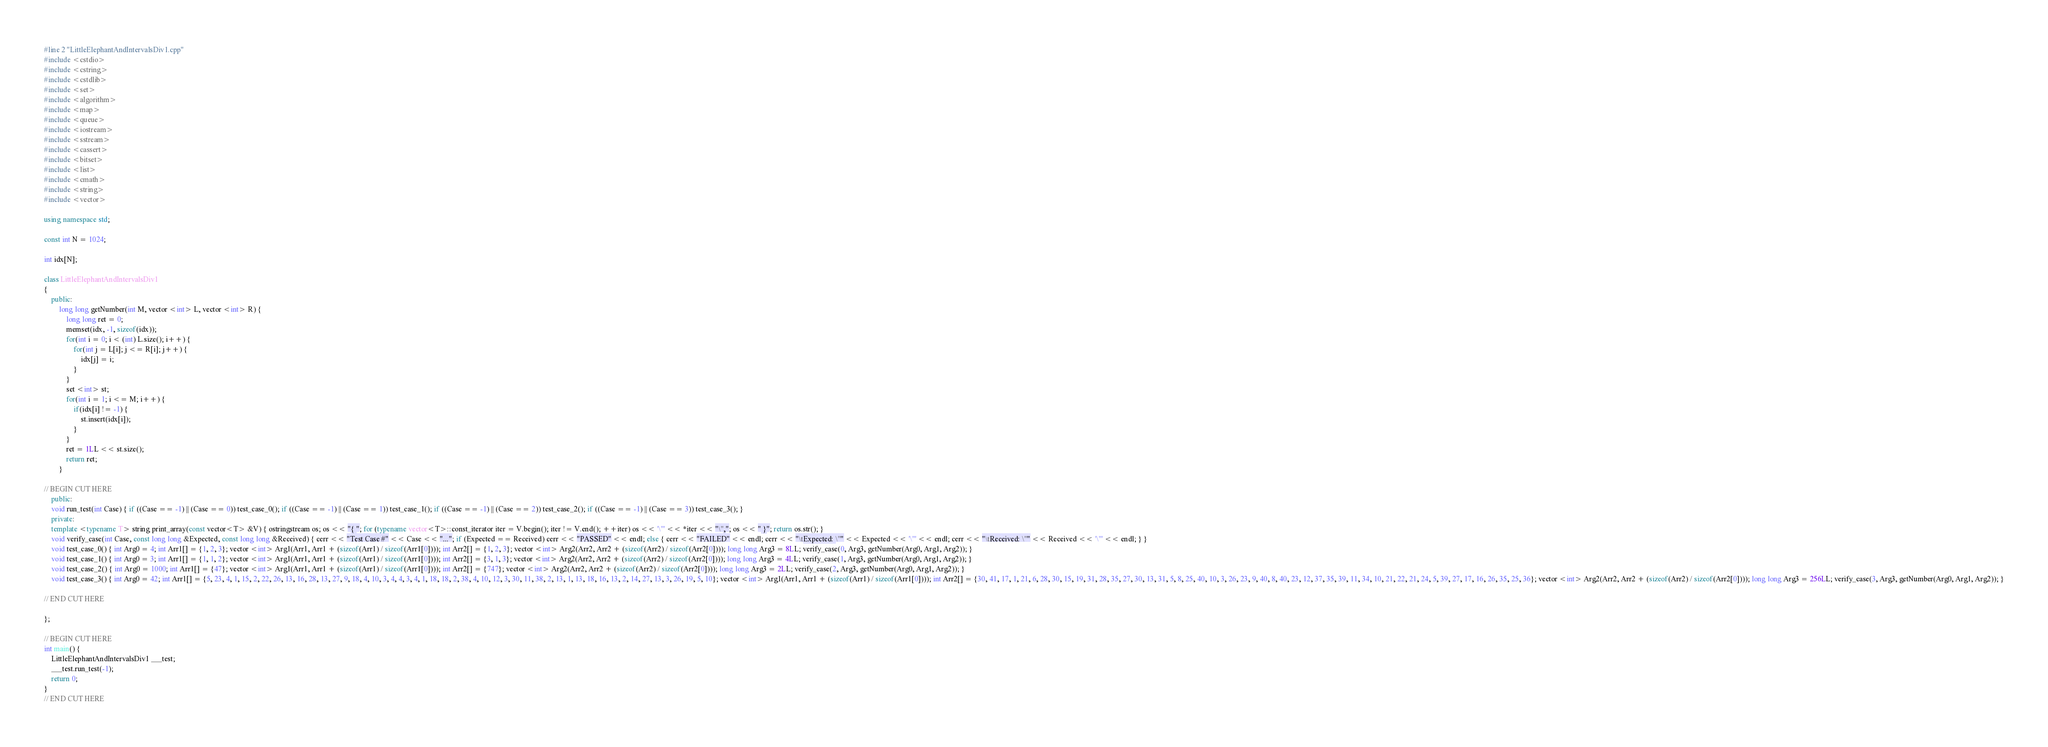Convert code to text. <code><loc_0><loc_0><loc_500><loc_500><_C++_>#line 2 "LittleElephantAndIntervalsDiv1.cpp"
#include <cstdio>
#include <cstring>
#include <cstdlib>
#include <set>
#include <algorithm>
#include <map>
#include <queue>
#include <iostream>
#include <sstream>
#include <cassert>
#include <bitset>
#include <list>
#include <cmath>
#include <string>
#include <vector>

using namespace std;

const int N = 1024;

int idx[N];

class LittleElephantAndIntervalsDiv1
{
	public:
		long long getNumber(int M, vector <int> L, vector <int> R) {
			long long ret = 0;
			memset(idx, -1, sizeof(idx));
			for(int i = 0; i < (int) L.size(); i++) {
				for(int j = L[i]; j <= R[i]; j++) {
					idx[j] = i;
				}
			}
			set <int> st;
			for(int i = 1; i <= M; i++) {
				if(idx[i] != -1) {
					st.insert(idx[i]);
				}
			}
			ret = 1LL << st.size();
			return ret;
		}

// BEGIN CUT HERE
	public:
	void run_test(int Case) { if ((Case == -1) || (Case == 0)) test_case_0(); if ((Case == -1) || (Case == 1)) test_case_1(); if ((Case == -1) || (Case == 2)) test_case_2(); if ((Case == -1) || (Case == 3)) test_case_3(); }
	private:
	template <typename T> string print_array(const vector<T> &V) { ostringstream os; os << "{ "; for (typename vector<T>::const_iterator iter = V.begin(); iter != V.end(); ++iter) os << '\"' << *iter << "\","; os << " }"; return os.str(); }
	void verify_case(int Case, const long long &Expected, const long long &Received) { cerr << "Test Case #" << Case << "..."; if (Expected == Received) cerr << "PASSED" << endl; else { cerr << "FAILED" << endl; cerr << "\tExpected: \"" << Expected << '\"' << endl; cerr << "\tReceived: \"" << Received << '\"' << endl; } }
	void test_case_0() { int Arg0 = 4; int Arr1[] = {1, 2, 3}; vector <int> Arg1(Arr1, Arr1 + (sizeof(Arr1) / sizeof(Arr1[0]))); int Arr2[] = {1, 2, 3}; vector <int> Arg2(Arr2, Arr2 + (sizeof(Arr2) / sizeof(Arr2[0]))); long long Arg3 = 8LL; verify_case(0, Arg3, getNumber(Arg0, Arg1, Arg2)); }
	void test_case_1() { int Arg0 = 3; int Arr1[] = {1, 1, 2}; vector <int> Arg1(Arr1, Arr1 + (sizeof(Arr1) / sizeof(Arr1[0]))); int Arr2[] = {3, 1, 3}; vector <int> Arg2(Arr2, Arr2 + (sizeof(Arr2) / sizeof(Arr2[0]))); long long Arg3 = 4LL; verify_case(1, Arg3, getNumber(Arg0, Arg1, Arg2)); }
	void test_case_2() { int Arg0 = 1000; int Arr1[] = {47}; vector <int> Arg1(Arr1, Arr1 + (sizeof(Arr1) / sizeof(Arr1[0]))); int Arr2[] = {747}; vector <int> Arg2(Arr2, Arr2 + (sizeof(Arr2) / sizeof(Arr2[0]))); long long Arg3 = 2LL; verify_case(2, Arg3, getNumber(Arg0, Arg1, Arg2)); }
	void test_case_3() { int Arg0 = 42; int Arr1[] = {5, 23, 4, 1, 15, 2, 22, 26, 13, 16, 28, 13, 27, 9, 18, 4, 10, 3, 4, 4, 3, 4, 1, 18, 18, 2, 38, 4, 10, 12, 3, 30, 11, 38, 2, 13, 1, 13, 18, 16, 13, 2, 14, 27, 13, 3, 26, 19, 5, 10}; vector <int> Arg1(Arr1, Arr1 + (sizeof(Arr1) / sizeof(Arr1[0]))); int Arr2[] = {30, 41, 17, 1, 21, 6, 28, 30, 15, 19, 31, 28, 35, 27, 30, 13, 31, 5, 8, 25, 40, 10, 3, 26, 23, 9, 40, 8, 40, 23, 12, 37, 35, 39, 11, 34, 10, 21, 22, 21, 24, 5, 39, 27, 17, 16, 26, 35, 25, 36}; vector <int> Arg2(Arr2, Arr2 + (sizeof(Arr2) / sizeof(Arr2[0]))); long long Arg3 = 256LL; verify_case(3, Arg3, getNumber(Arg0, Arg1, Arg2)); }

// END CUT HERE

};

// BEGIN CUT HERE
int main() {
	LittleElephantAndIntervalsDiv1 ___test;
	___test.run_test(-1);
	return 0;
}
// END CUT HERE
</code> 